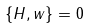Convert formula to latex. <formula><loc_0><loc_0><loc_500><loc_500>\{ H , w \} = 0</formula> 